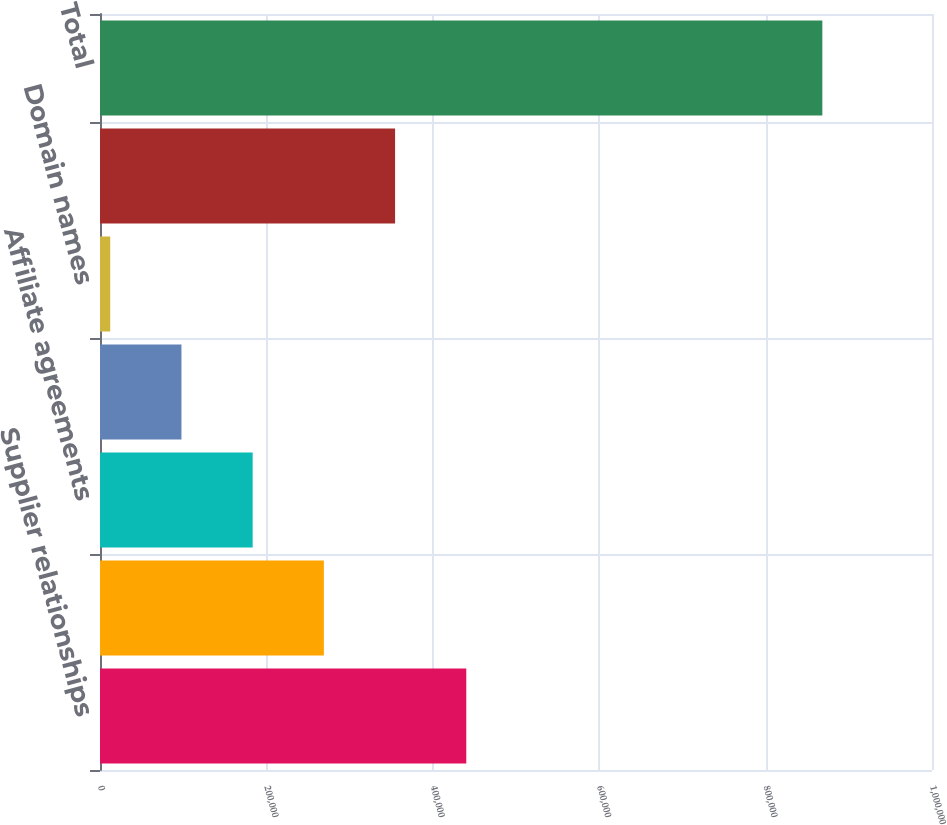Convert chart. <chart><loc_0><loc_0><loc_500><loc_500><bar_chart><fcel>Supplier relationships<fcel>Technology<fcel>Affiliate agreements<fcel>Customer lists<fcel>Domain names<fcel>Other<fcel>Total<nl><fcel>440256<fcel>269078<fcel>183488<fcel>97898.5<fcel>12309<fcel>354667<fcel>868204<nl></chart> 